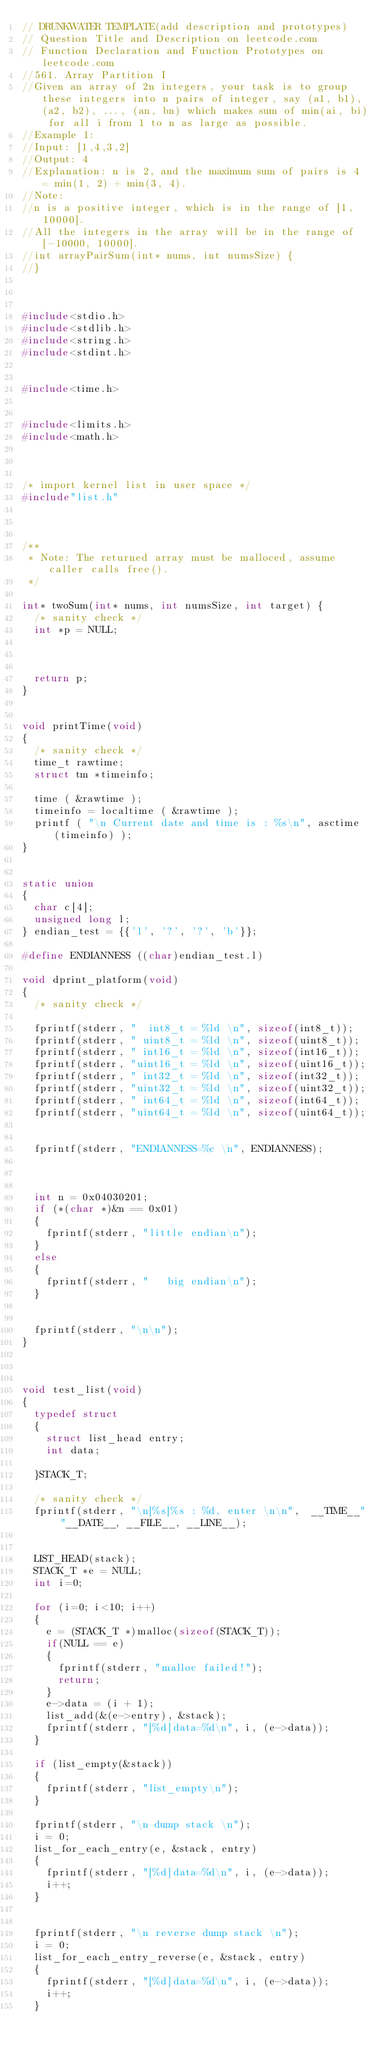Convert code to text. <code><loc_0><loc_0><loc_500><loc_500><_C_>// DRUNKWATER TEMPLATE(add description and prototypes)
// Question Title and Description on leetcode.com
// Function Declaration and Function Prototypes on leetcode.com
//561. Array Partition I
//Given an array of 2n integers, your task is to group these integers into n pairs of integer, say (a1, b1), (a2, b2), ..., (an, bn) which makes sum of min(ai, bi) for all i from 1 to n as large as possible.
//Example 1:
//Input: [1,4,3,2]
//Output: 4
//Explanation: n is 2, and the maximum sum of pairs is 4 = min(1, 2) + min(3, 4).
//Note:
//n is a positive integer, which is in the range of [1, 10000].
//All the integers in the array will be in the range of [-10000, 10000].
//int arrayPairSum(int* nums, int numsSize) {
//}



#include<stdio.h>
#include<stdlib.h>
#include<string.h>
#include<stdint.h>


#include<time.h>


#include<limits.h>
#include<math.h>



/* import kernel list in user space */
#include"list.h"



/**
 * Note: The returned array must be malloced, assume caller calls free().
 */

int* twoSum(int* nums, int numsSize, int target) {
	/* sanity check */
	int *p = NULL;



	return p;
}


void printTime(void)
{
	/* sanity check */
	time_t rawtime;
	struct tm *timeinfo;

	time ( &rawtime );
	timeinfo = localtime ( &rawtime );
	printf ( "\n Current date and time is : %s\n", asctime (timeinfo) );
}


static union
{
	char c[4];
	unsigned long l;
} endian_test = {{'l', '?', '?', 'b'}};

#define ENDIANNESS ((char)endian_test.l)

void dprint_platform(void)
{
	/* sanity check */

	fprintf(stderr, "  int8_t = %ld \n", sizeof(int8_t));
	fprintf(stderr, " uint8_t = %ld \n", sizeof(uint8_t));
	fprintf(stderr, " int16_t = %ld \n", sizeof(int16_t));
	fprintf(stderr, "uint16_t = %ld \n", sizeof(uint16_t));
	fprintf(stderr, " int32_t = %ld \n", sizeof(int32_t));
	fprintf(stderr, "uint32_t = %ld \n", sizeof(uint32_t));
	fprintf(stderr, " int64_t = %ld \n", sizeof(int64_t));
	fprintf(stderr, "uint64_t = %ld \n", sizeof(uint64_t));


	fprintf(stderr, "ENDIANNESS=%c \n", ENDIANNESS);



	int n = 0x04030201;
	if (*(char *)&n == 0x01)
	{
		fprintf(stderr, "little endian\n");
	}
	else
	{
		fprintf(stderr, "   big endian\n");
	}


	fprintf(stderr, "\n\n");
}



void test_list(void)
{
	typedef struct
	{
		struct list_head entry;
		int data;
	
	}STACK_T;

	/* sanity check */
	fprintf(stderr, "\n[%s]%s : %d, enter \n\n",  __TIME__" "__DATE__, __FILE__, __LINE__);


	LIST_HEAD(stack);
	STACK_T *e = NULL;
	int i=0;

	for (i=0; i<10; i++)
	{
		e = (STACK_T *)malloc(sizeof(STACK_T));
		if(NULL == e)
		{
			fprintf(stderr, "malloc failed!");
			return;
		}
		e->data = (i + 1);
		list_add(&(e->entry), &stack);
		fprintf(stderr, "[%d]data=%d\n", i, (e->data));
	}

	if (list_empty(&stack))
	{
		fprintf(stderr, "list_empty\n");
	}

	fprintf(stderr, "\n dump stack \n");
	i = 0;
	list_for_each_entry(e, &stack, entry)
	{
		fprintf(stderr, "[%d]data=%d\n", i, (e->data));
		i++;
	}


	fprintf(stderr, "\n reverse dump stack \n");
	i = 0;
	list_for_each_entry_reverse(e, &stack, entry)
	{
		fprintf(stderr, "[%d]data=%d\n", i, (e->data));
		i++;
	}

</code> 